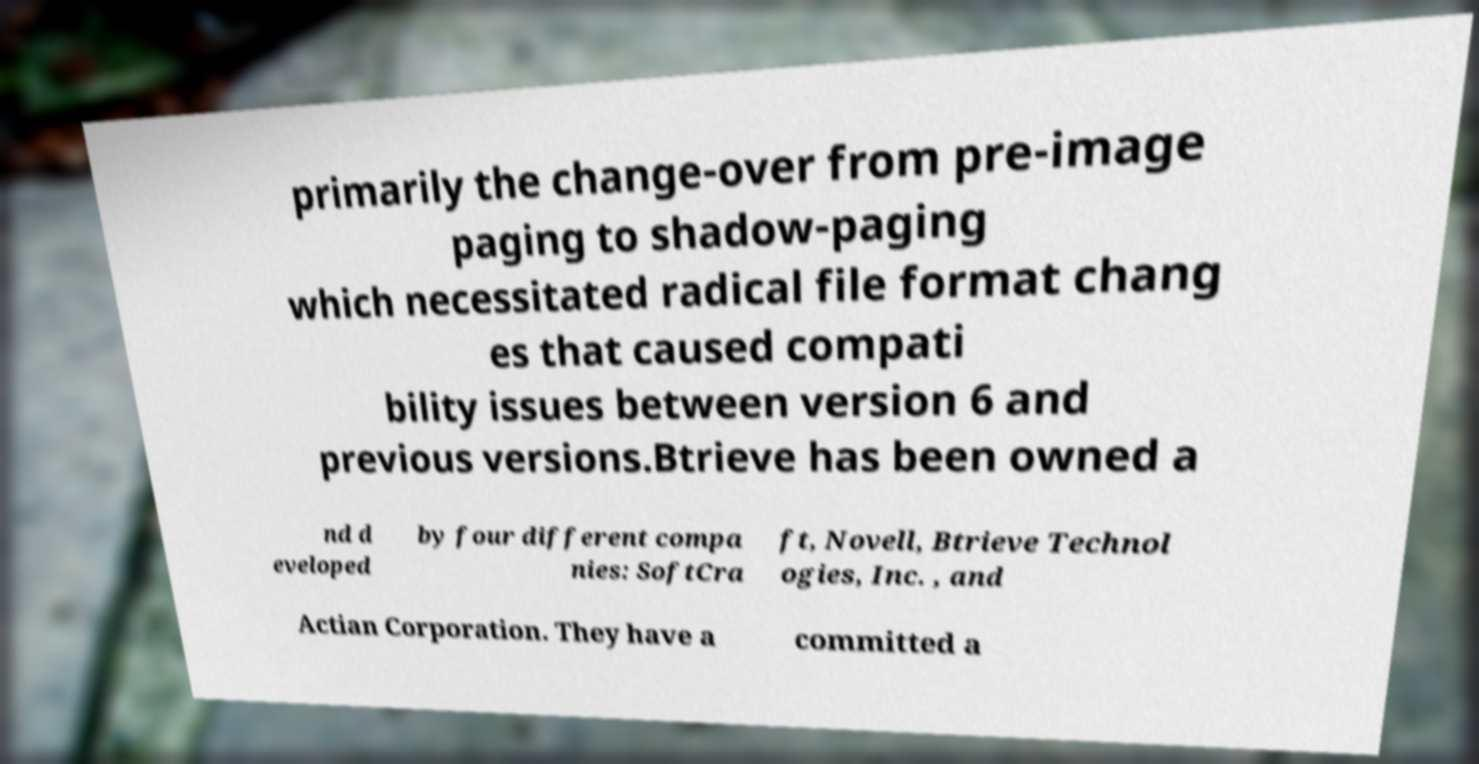For documentation purposes, I need the text within this image transcribed. Could you provide that? primarily the change-over from pre-image paging to shadow-paging which necessitated radical file format chang es that caused compati bility issues between version 6 and previous versions.Btrieve has been owned a nd d eveloped by four different compa nies: SoftCra ft, Novell, Btrieve Technol ogies, Inc. , and Actian Corporation. They have a committed a 